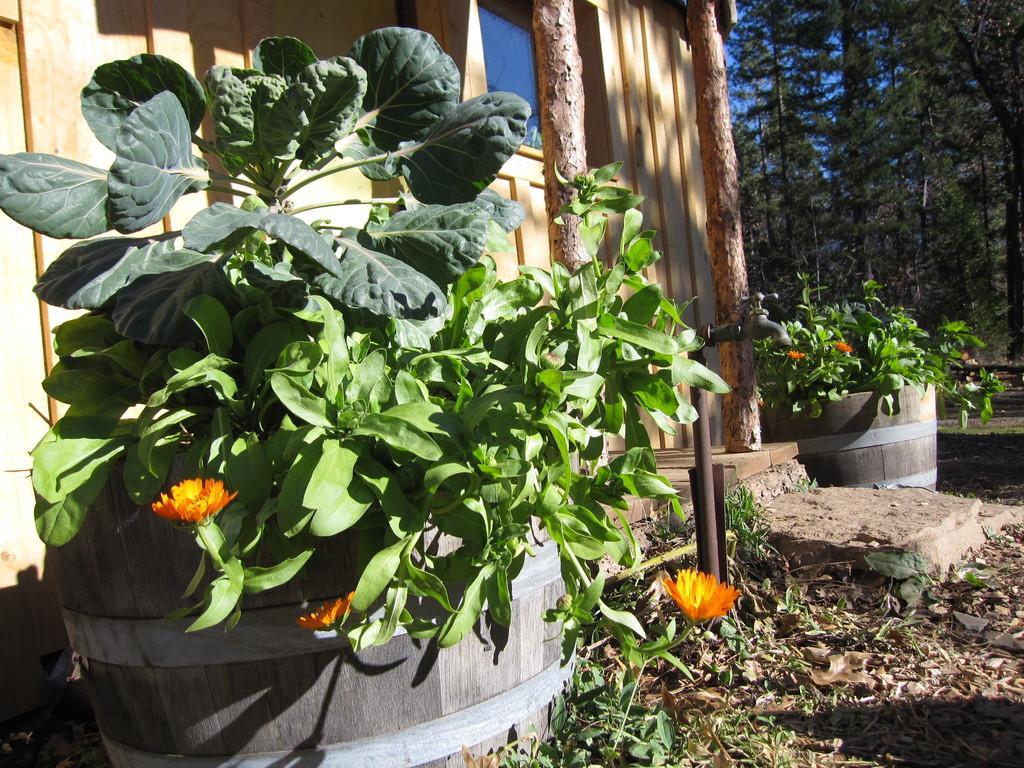Can you describe this image briefly? In this picture there is a green plant in the wooden pot placed on the ground. Behind there is a wooden house and some trees in the background. 